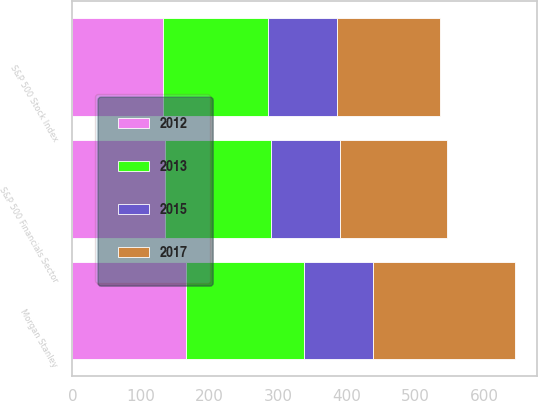Convert chart. <chart><loc_0><loc_0><loc_500><loc_500><stacked_bar_chart><ecel><fcel>Morgan Stanley<fcel>S&P 500 Stock Index<fcel>S&P 500 Financials Sector<nl><fcel>2015<fcel>100<fcel>100<fcel>100<nl><fcel>2012<fcel>165.33<fcel>132.37<fcel>135.59<nl><fcel>2017<fcel>206.81<fcel>150.48<fcel>156.17<nl><fcel>2013<fcel>172.16<fcel>152.55<fcel>153.73<nl></chart> 